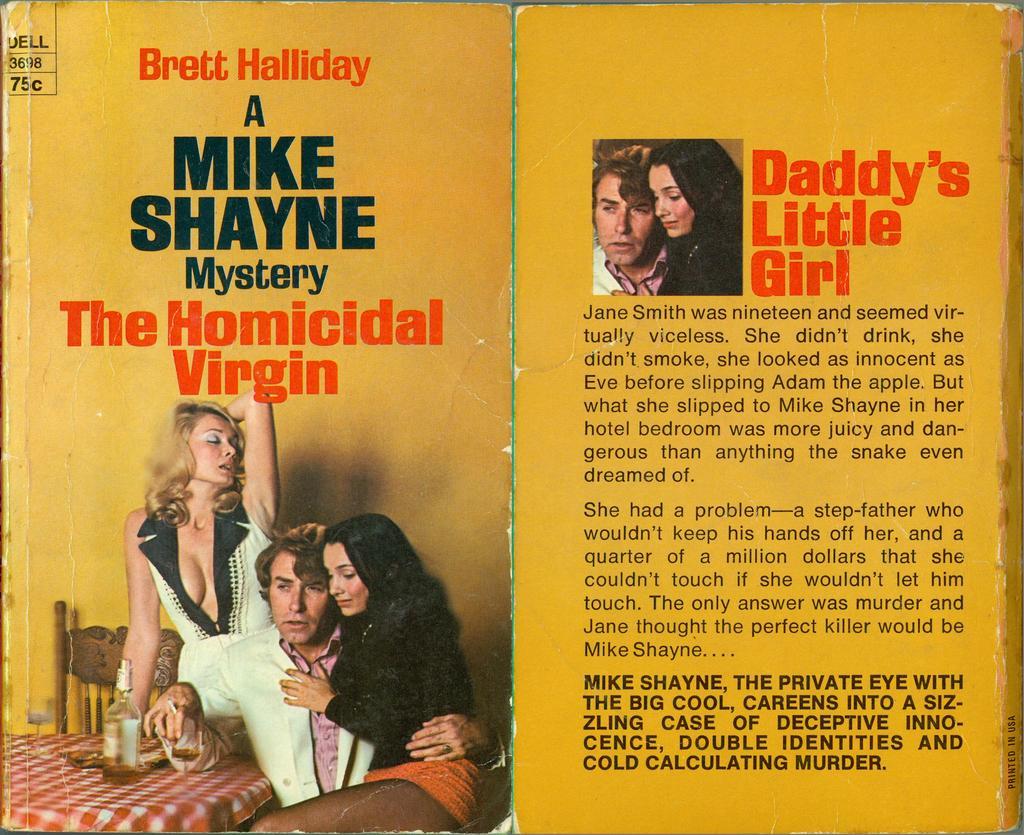Describe this image in one or two sentences. This is the picture of a magazine on which some things are written with black, red and white color and there are two images on it. 